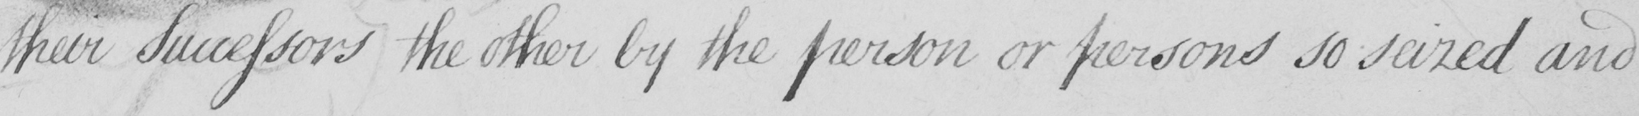Please transcribe the handwritten text in this image. [their Successors the other by the person or persons so seized and 